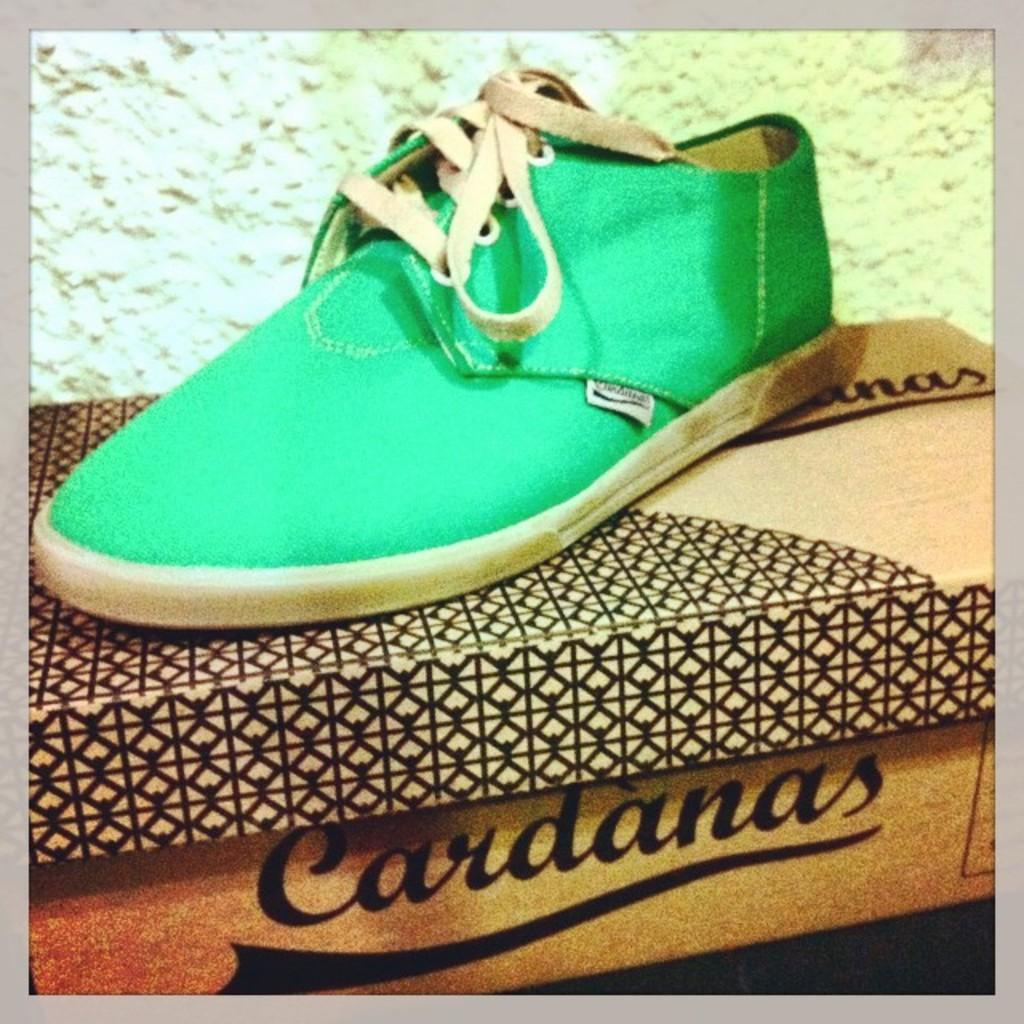What object is the main focus of the image? There is a shoe in the image. Where is the shoe placed? The shoe is on a cardboard box. Can you describe the background of the image? The background of the image is blurred. What type of shirt is hanging on the window in the image? There is no shirt or window present in the image; it only features a shoe on a cardboard box with a blurred background. 